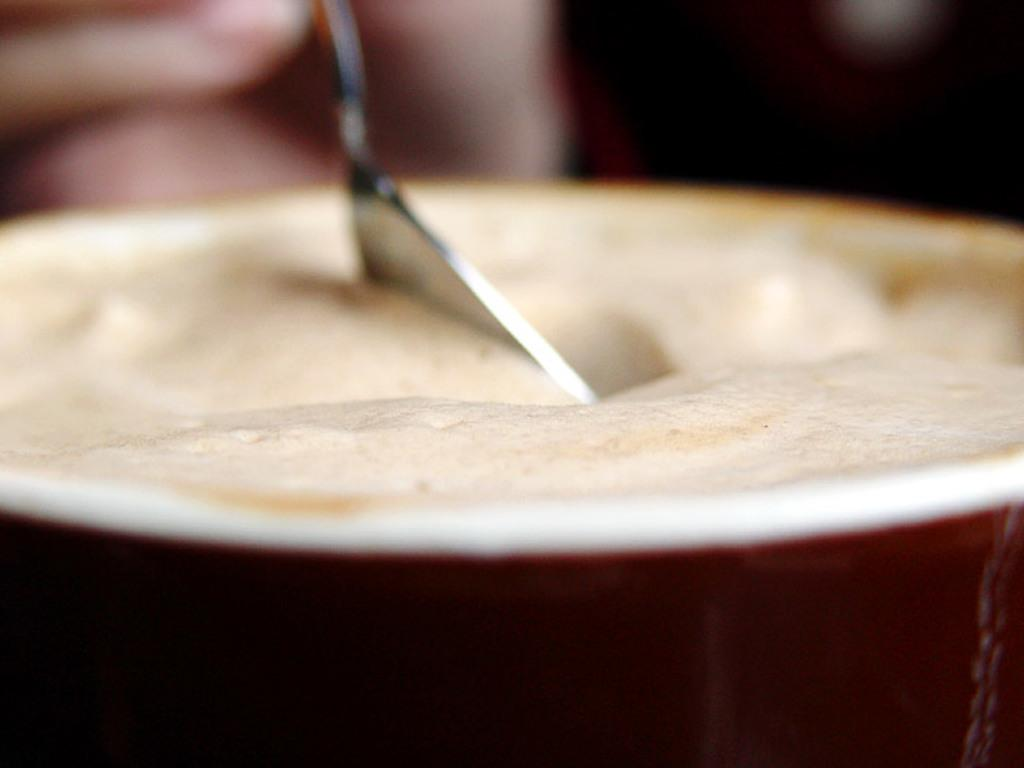What is the main object in the center of the image? There is a coffee cup in the center of the image. What is inside the coffee cup? There is coffee in the cup. Can you describe the human hand and its position in the image? There is a human hand holding a spoon in the left top of the image. What type of religion is being practiced by the person holding the spoon in the image? There is no indication of any religious practice in the image, as it only features a coffee cup, coffee, and a human hand holding a spoon. 